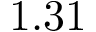Convert formula to latex. <formula><loc_0><loc_0><loc_500><loc_500>1 . 3 1</formula> 